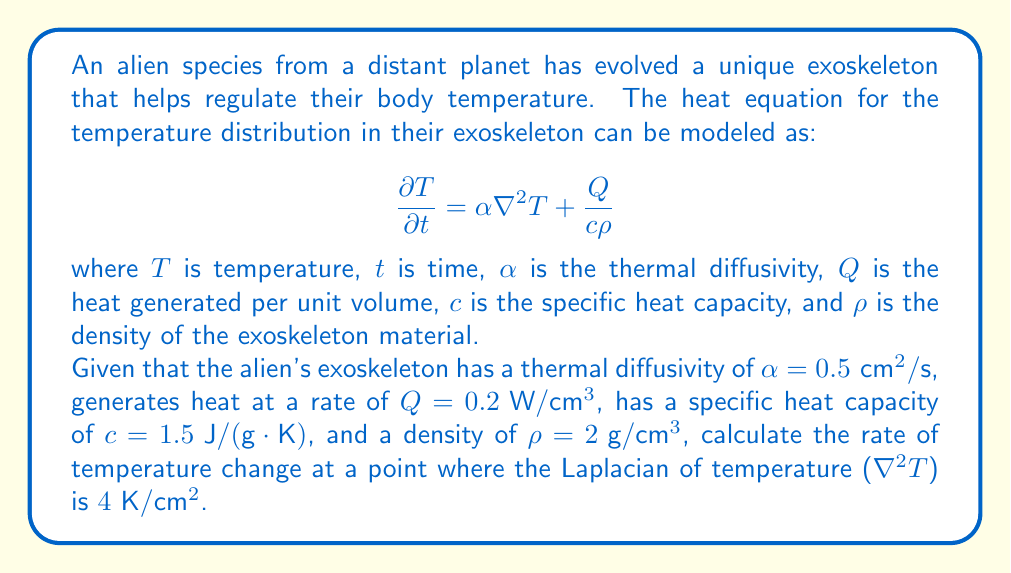What is the answer to this math problem? To solve this problem, we'll follow these steps:

1) We start with the given heat equation:

   $$\frac{\partial T}{\partial t} = \alpha \nabla^2 T + \frac{Q}{c\rho}$$

2) We're given the following values:
   - $\alpha = 0.5 \text{ cm}^2/\text{s}$
   - $Q = 0.2 \text{ W}/\text{cm}^3$
   - $c = 1.5 \text{ J}/(\text{g}\cdot\text{K})$
   - $\rho = 2 \text{ g}/\text{cm}^3$
   - $\nabla^2 T = 4 \text{ K}/\text{cm}^2$

3) Let's substitute these values into the equation:

   $$\frac{\partial T}{\partial t} = 0.5 \text{ cm}^2/\text{s} \cdot 4 \text{ K}/\text{cm}^2 + \frac{0.2 \text{ W}/\text{cm}^3}{1.5 \text{ J}/(\text{g}\cdot\text{K}) \cdot 2 \text{ g}/\text{cm}^3}$$

4) Simplify the first term:
   
   $$0.5 \text{ cm}^2/\text{s} \cdot 4 \text{ K}/\text{cm}^2 = 2 \text{ K}/\text{s}$$

5) Simplify the second term:
   
   $$\frac{0.2 \text{ W}/\text{cm}^3}{1.5 \text{ J}/(\text{g}\cdot\text{K}) \cdot 2 \text{ g}/\text{cm}^3} = \frac{0.2}{3} \text{ K}/\text{s} \approx 0.0667 \text{ K}/\text{s}$$

6) Sum up the terms:

   $$\frac{\partial T}{\partial t} = 2 \text{ K}/\text{s} + 0.0667 \text{ K}/\text{s} = 2.0667 \text{ K}/\text{s}$$

Therefore, the rate of temperature change at the given point is approximately 2.0667 K/s.
Answer: 2.0667 K/s 